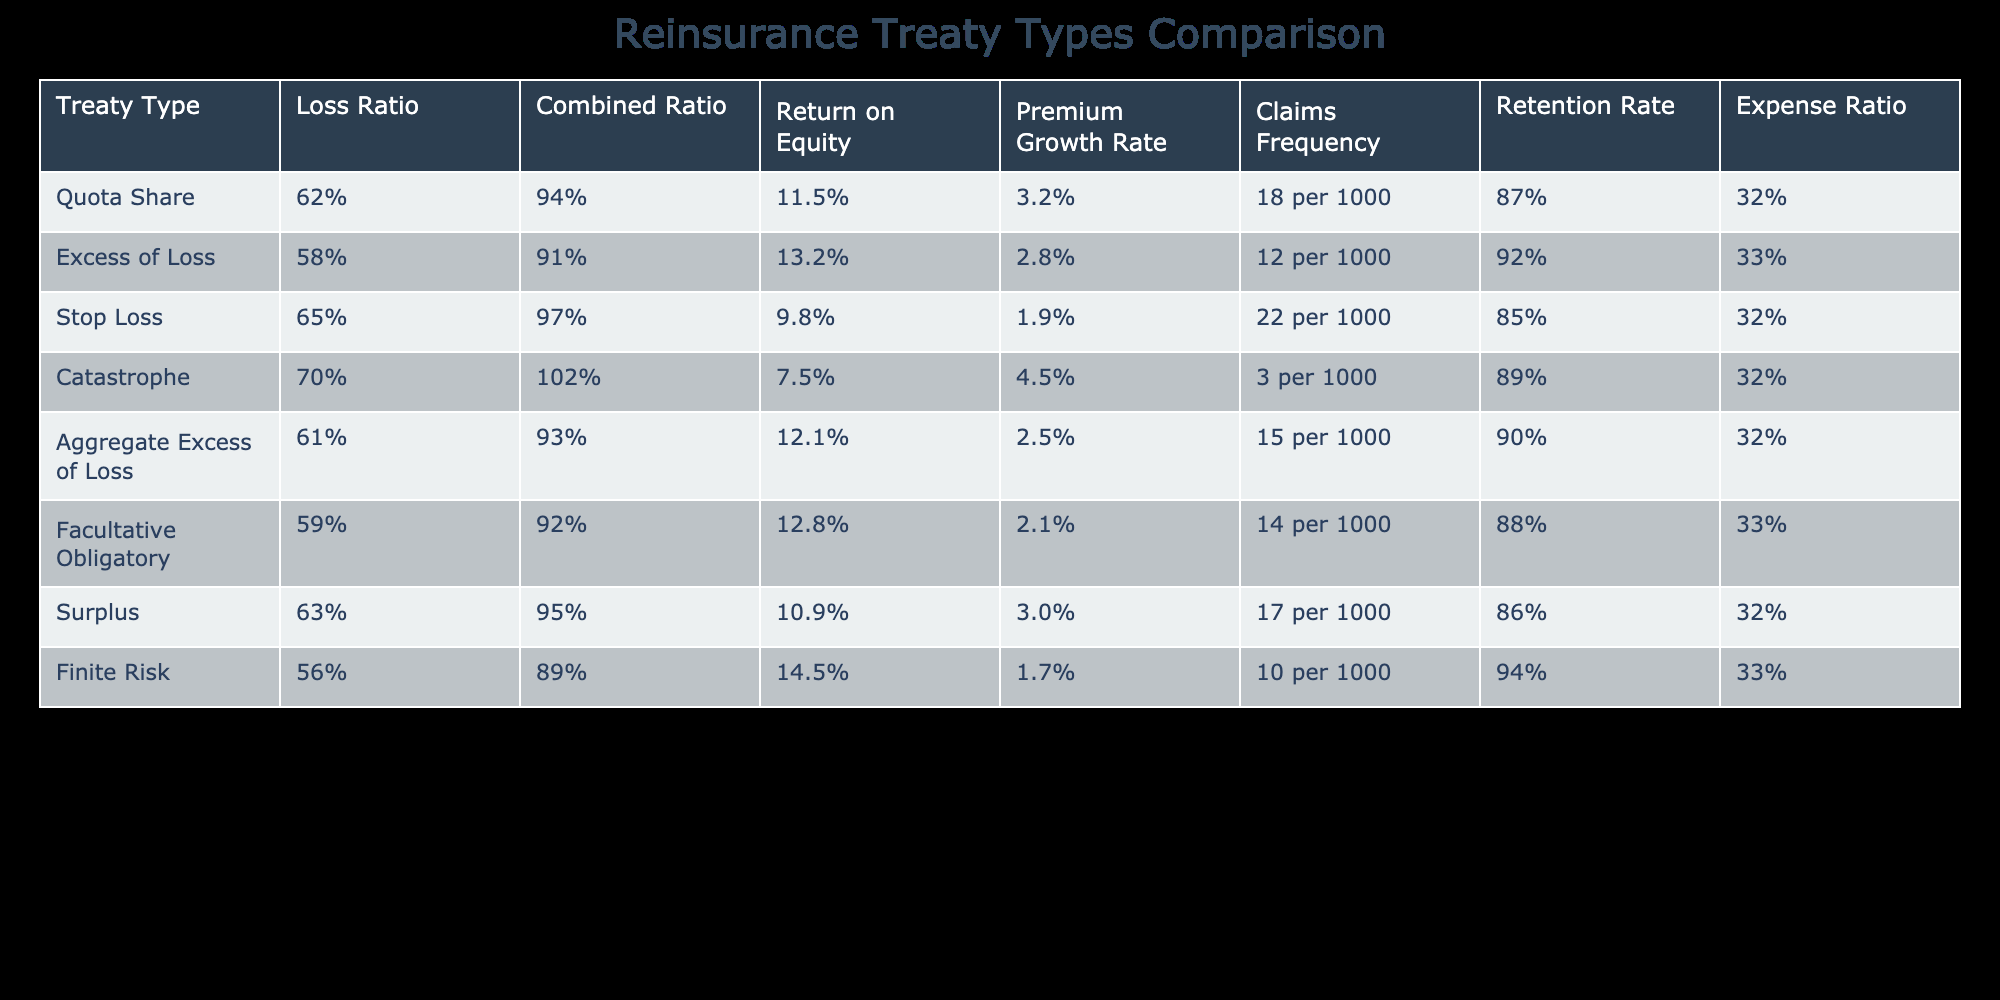What is the loss ratio for Excess of Loss treaty type? The loss ratio is listed directly in the table under the "Loss Ratio" column for the Excess of Loss treaty type, which is 58%.
Answer: 58% Which treaty type has the highest return on equity? To find the highest return on equity, we need to compare the values in the "Return on Equity" column. The highest value is 14.5% for the Finite Risk treaty type.
Answer: 14.5% What is the average claims frequency across all treaty types? First, we convert the claims frequency rates from their format into numerical form: 18, 12, 22, 3, 15, 14, 17, and 10. Summing them gives us 18 + 12 + 22 + 3 + 15 + 14 + 17 + 10 = 121. There are 8 treaty types, so the average claims frequency is 121 / 8 = 15.125.
Answer: 15.125 Does the Catastrophe treaty type have a combined ratio higher than 100? We can reference the "Combined Ratio" column for the Catastrophe treaty type, which shows a value of 102. Since this is greater than 100, the statement is true.
Answer: Yes Which treaty type has the lowest expense ratio? By examining the "Expense Ratio" column, we identify the lowest value, which is 32% for Quota Share, Stop Loss, Aggregate Excess of Loss, Facultative Obligatory, and Surplus treaty types, but since there are multiple minimums, the answer reflects those that share this value.
Answer: 32% (multiple treaty types) What is the combined ratio for the Finite Risk treaty type compared to the average of all treaty types? The combined ratio for Finite Risk is listed as 89%. To find the average, we sum the combined ratios: 94, 91, 97, 102, 93, 92, 95, and 89, which equals 749. Dividing by 8 gives us an average of 93.625. Since 89% is lower than 93.625%, it shows that Finite Risk is below average.
Answer: Below average Which treaty type shows the highest premium growth rate? We need to look for the highest value in the "Premium Growth Rate" column. The value for Catastrophe treaty type is 4.5%, which is the highest compared to others listed in the table.
Answer: 4.5% Is the retention rate for Stop Loss treaty type greater than that of Quota Share? The retention rate for Stop Loss is 85% and for Quota Share it is 87%. Comparatively, 85% is less than 87%, indicating that Stop Loss has a lower retention rate than Quota Share.
Answer: No What is the loss ratio difference between the Quota Share and Aggregate Excess of Loss treaty types? The loss ratio for Quota Share is 62% and for Aggregate Excess of Loss, it is 61%. The difference is consequently calculated as 62% - 61% = 1%.
Answer: 1% 